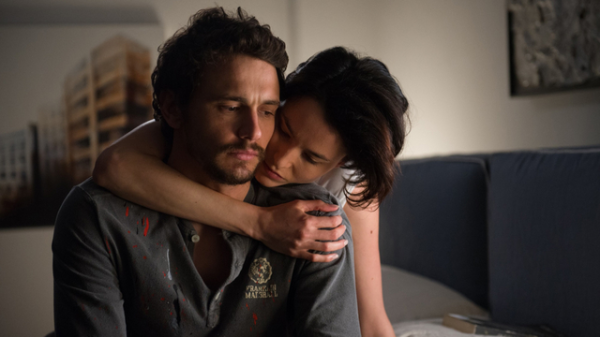Can you elaborate on the elements of the picture provided? The image captures an intimate scene between a man and woman. The man, appearing weary with eyes closed, wears a grey shirt with what seems to be red spatter and a badge marked 'Marshal.' The woman, showing affection and concern, kisses him gently on the forehead. They are seated on a dark blue sofa in a dimly lit room, which suggests a personal and private moment. This setting, combined with their expressions and close proximity, conveys a sense of comfort and mutual care amidst potentially troubling circumstances. 